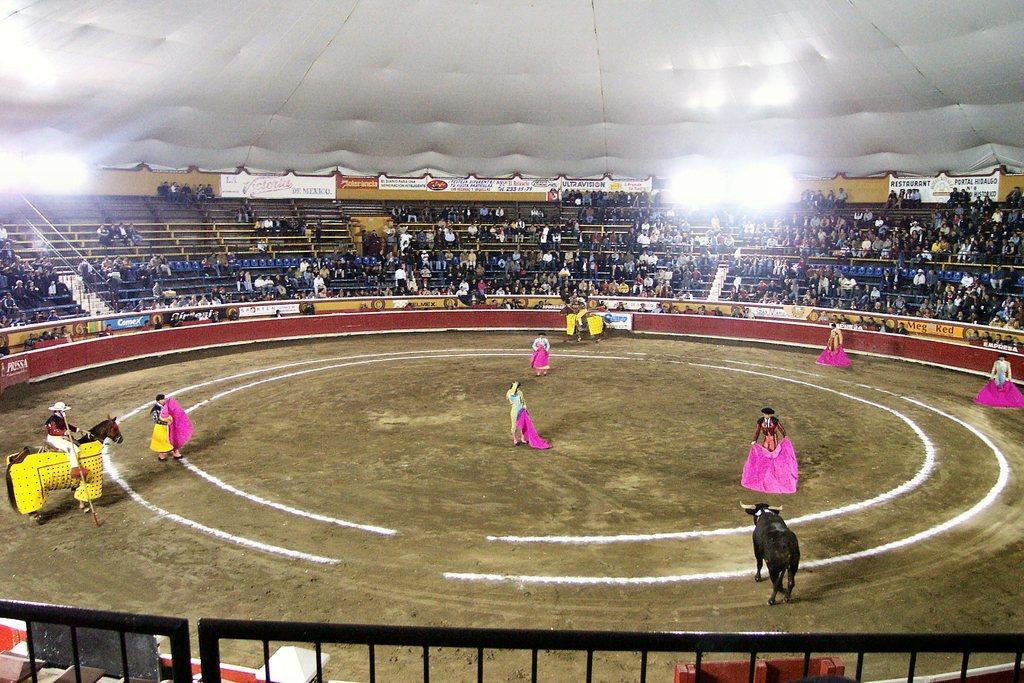Who or what can be seen in the image? There are people and horses on the ground in the image. What is one person doing in the image? One person is holding a stick. What can be seen in the background of the image? There is a fence, advertisement boards, people, and a roof visible in the background of the image. How many fires can be seen in the image? There is no fire present in the image. 